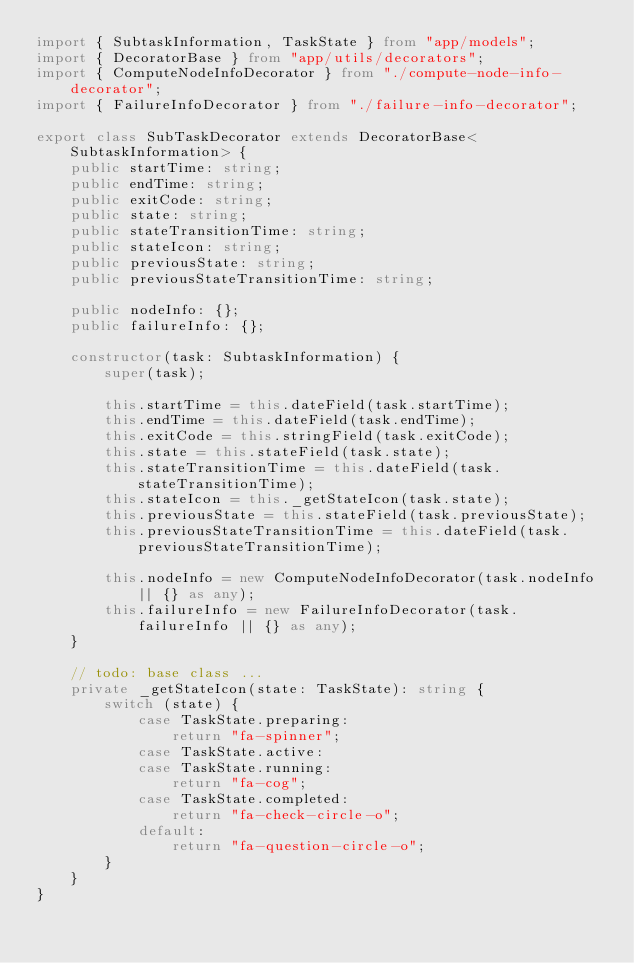Convert code to text. <code><loc_0><loc_0><loc_500><loc_500><_TypeScript_>import { SubtaskInformation, TaskState } from "app/models";
import { DecoratorBase } from "app/utils/decorators";
import { ComputeNodeInfoDecorator } from "./compute-node-info-decorator";
import { FailureInfoDecorator } from "./failure-info-decorator";

export class SubTaskDecorator extends DecoratorBase<SubtaskInformation> {
    public startTime: string;
    public endTime: string;
    public exitCode: string;
    public state: string;
    public stateTransitionTime: string;
    public stateIcon: string;
    public previousState: string;
    public previousStateTransitionTime: string;

    public nodeInfo: {};
    public failureInfo: {};

    constructor(task: SubtaskInformation) {
        super(task);

        this.startTime = this.dateField(task.startTime);
        this.endTime = this.dateField(task.endTime);
        this.exitCode = this.stringField(task.exitCode);
        this.state = this.stateField(task.state);
        this.stateTransitionTime = this.dateField(task.stateTransitionTime);
        this.stateIcon = this._getStateIcon(task.state);
        this.previousState = this.stateField(task.previousState);
        this.previousStateTransitionTime = this.dateField(task.previousStateTransitionTime);

        this.nodeInfo = new ComputeNodeInfoDecorator(task.nodeInfo || {} as any);
        this.failureInfo = new FailureInfoDecorator(task.failureInfo || {} as any);
    }

    // todo: base class ...
    private _getStateIcon(state: TaskState): string {
        switch (state) {
            case TaskState.preparing:
                return "fa-spinner";
            case TaskState.active:
            case TaskState.running:
                return "fa-cog";
            case TaskState.completed:
                return "fa-check-circle-o";
            default:
                return "fa-question-circle-o";
        }
    }
}
</code> 